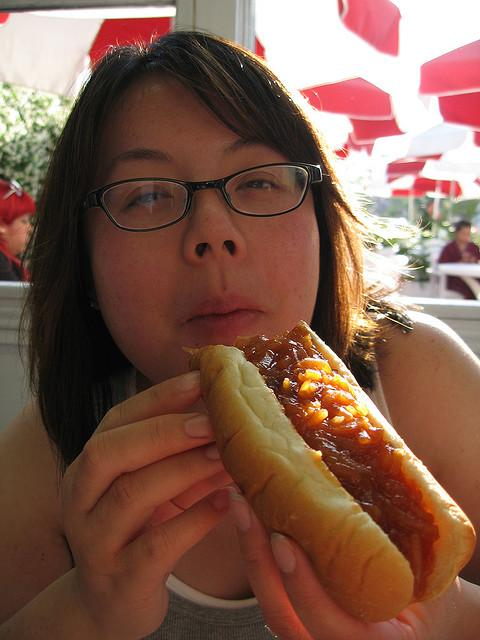In what place was the bread eaten here cooked? restaurant 